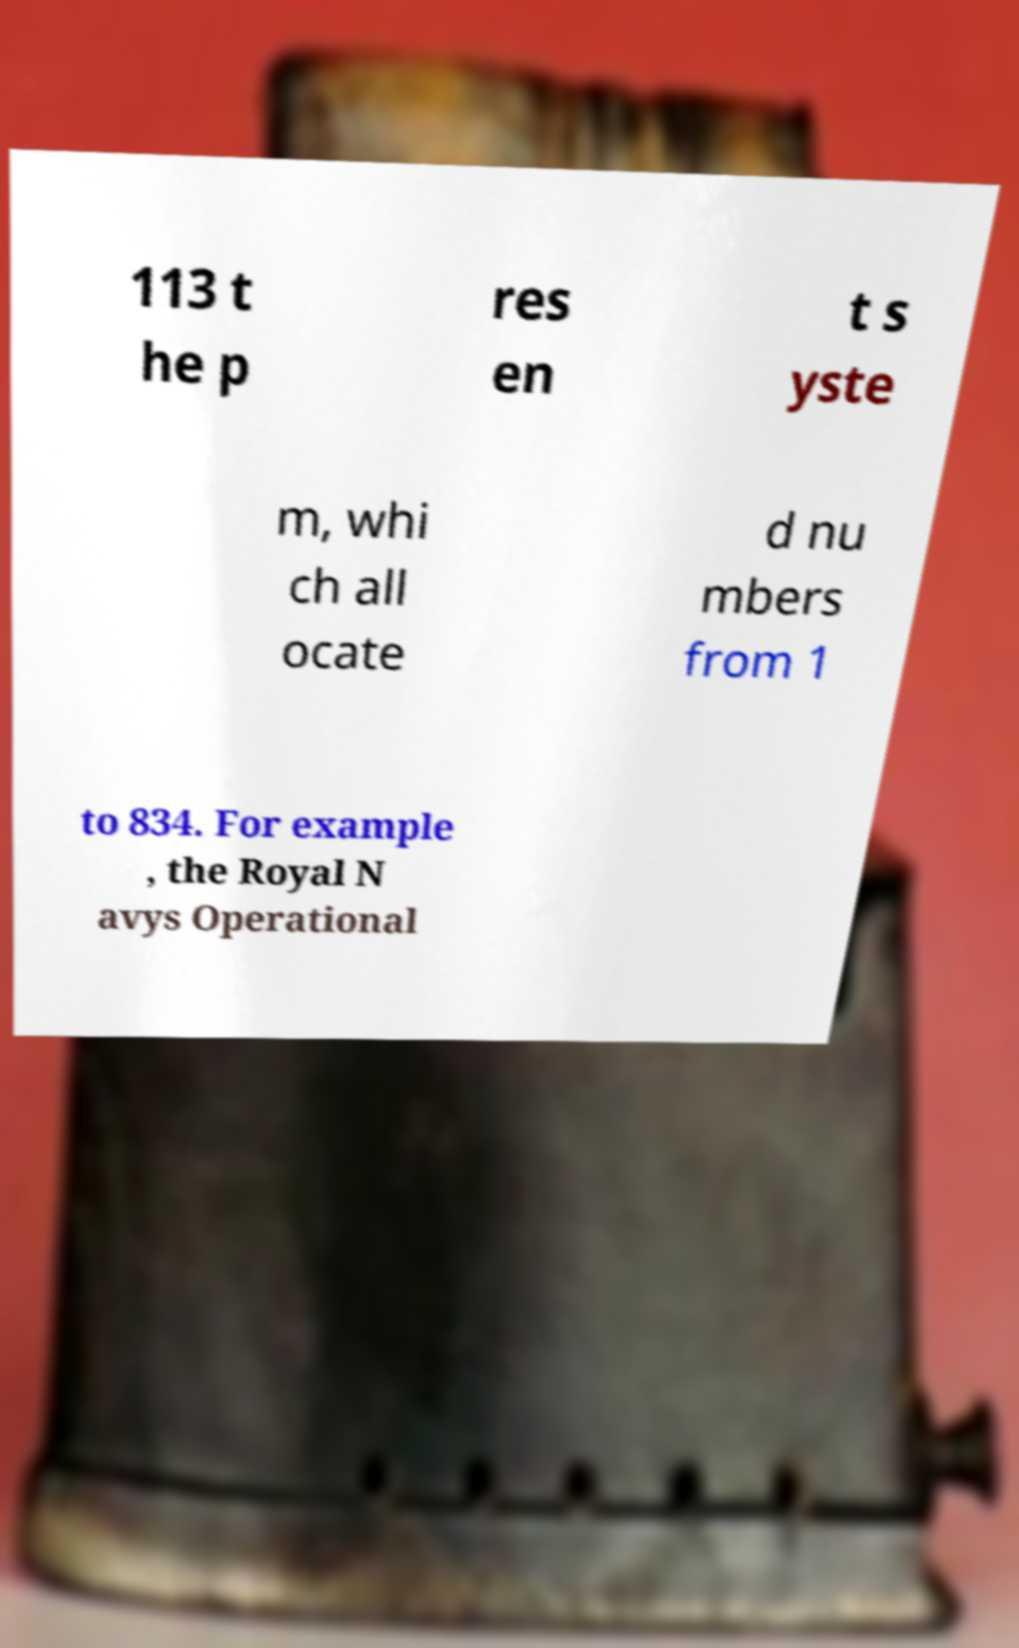I need the written content from this picture converted into text. Can you do that? 113 t he p res en t s yste m, whi ch all ocate d nu mbers from 1 to 834. For example , the Royal N avys Operational 